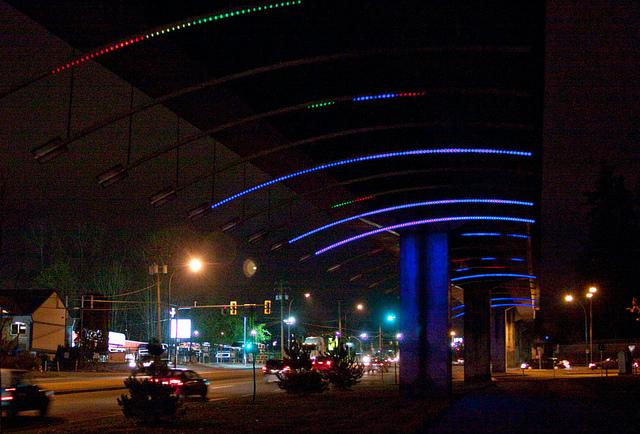The area underneath the structure is illuminated by what? led lights 